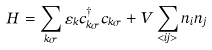<formula> <loc_0><loc_0><loc_500><loc_500>H = \sum _ { { k } \sigma } \varepsilon _ { k } c _ { { k } \sigma } ^ { \dagger } c _ { { k } \sigma } + V \sum _ { < i j > } n _ { i } n _ { j }</formula> 